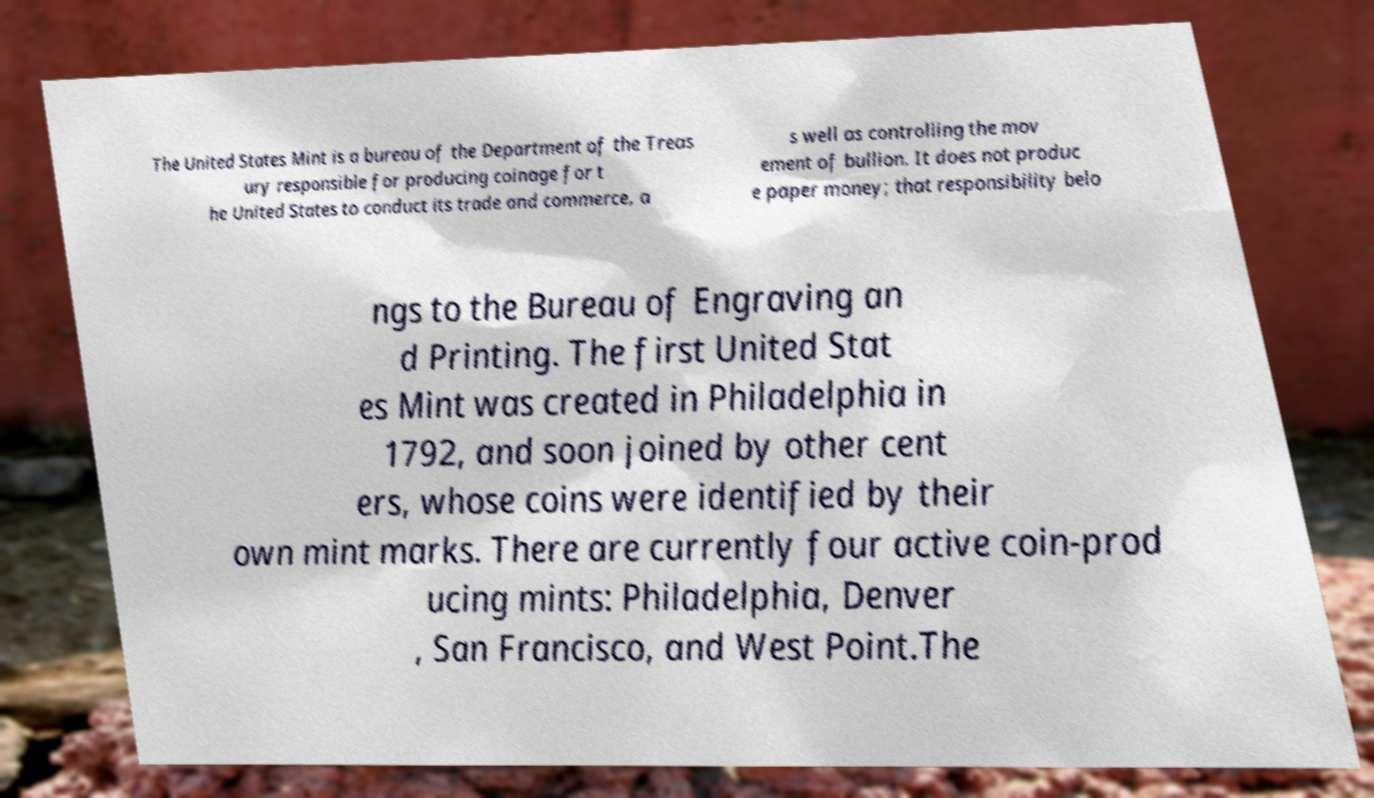I need the written content from this picture converted into text. Can you do that? The United States Mint is a bureau of the Department of the Treas ury responsible for producing coinage for t he United States to conduct its trade and commerce, a s well as controlling the mov ement of bullion. It does not produc e paper money; that responsibility belo ngs to the Bureau of Engraving an d Printing. The first United Stat es Mint was created in Philadelphia in 1792, and soon joined by other cent ers, whose coins were identified by their own mint marks. There are currently four active coin-prod ucing mints: Philadelphia, Denver , San Francisco, and West Point.The 